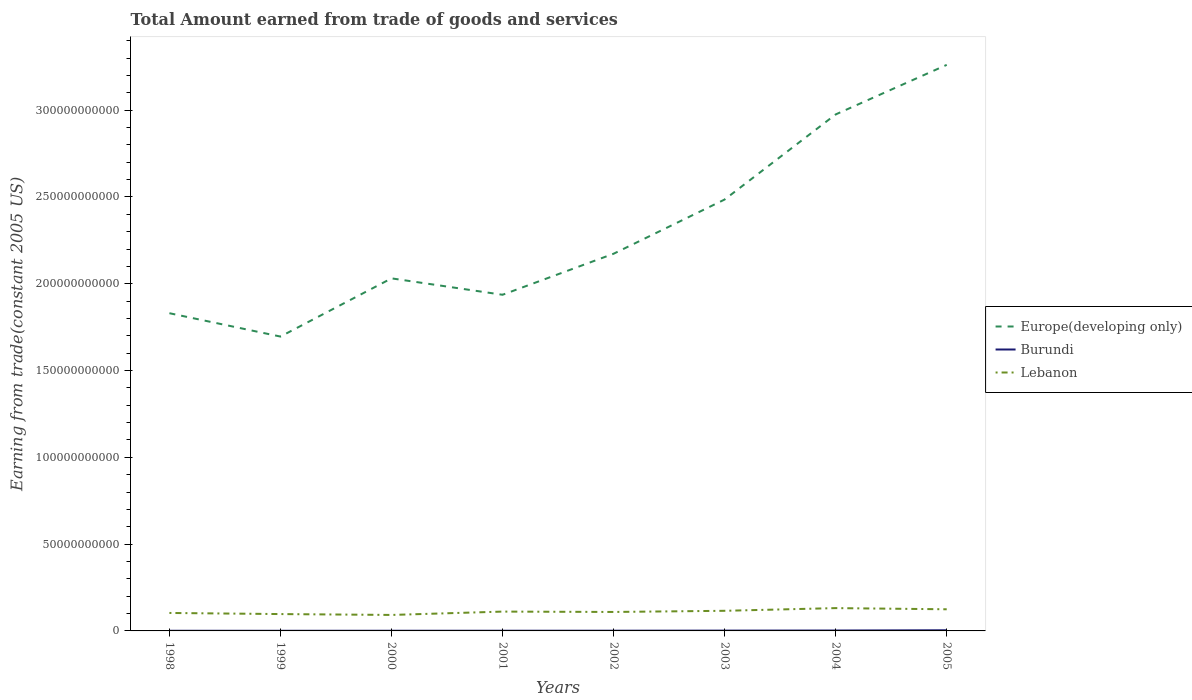Does the line corresponding to Lebanon intersect with the line corresponding to Burundi?
Ensure brevity in your answer.  No. Across all years, what is the maximum total amount earned by trading goods and services in Europe(developing only)?
Give a very brief answer. 1.70e+11. In which year was the total amount earned by trading goods and services in Europe(developing only) maximum?
Keep it short and to the point. 1999. What is the total total amount earned by trading goods and services in Lebanon in the graph?
Make the answer very short. -3.26e+09. What is the difference between the highest and the second highest total amount earned by trading goods and services in Europe(developing only)?
Your response must be concise. 1.57e+11. How many years are there in the graph?
Your response must be concise. 8. Are the values on the major ticks of Y-axis written in scientific E-notation?
Offer a terse response. No. Does the graph contain any zero values?
Ensure brevity in your answer.  No. Does the graph contain grids?
Provide a short and direct response. No. What is the title of the graph?
Offer a very short reply. Total Amount earned from trade of goods and services. What is the label or title of the X-axis?
Give a very brief answer. Years. What is the label or title of the Y-axis?
Provide a succinct answer. Earning from trade(constant 2005 US). What is the Earning from trade(constant 2005 US) of Europe(developing only) in 1998?
Ensure brevity in your answer.  1.83e+11. What is the Earning from trade(constant 2005 US) of Burundi in 1998?
Offer a very short reply. 9.18e+07. What is the Earning from trade(constant 2005 US) of Lebanon in 1998?
Your answer should be very brief. 1.04e+1. What is the Earning from trade(constant 2005 US) of Europe(developing only) in 1999?
Provide a succinct answer. 1.70e+11. What is the Earning from trade(constant 2005 US) in Burundi in 1999?
Ensure brevity in your answer.  8.37e+07. What is the Earning from trade(constant 2005 US) of Lebanon in 1999?
Your response must be concise. 9.71e+09. What is the Earning from trade(constant 2005 US) in Europe(developing only) in 2000?
Your answer should be compact. 2.03e+11. What is the Earning from trade(constant 2005 US) in Burundi in 2000?
Make the answer very short. 9.42e+07. What is the Earning from trade(constant 2005 US) of Lebanon in 2000?
Offer a terse response. 9.20e+09. What is the Earning from trade(constant 2005 US) in Europe(developing only) in 2001?
Provide a succinct answer. 1.94e+11. What is the Earning from trade(constant 2005 US) of Burundi in 2001?
Offer a terse response. 1.10e+08. What is the Earning from trade(constant 2005 US) of Lebanon in 2001?
Offer a very short reply. 1.11e+1. What is the Earning from trade(constant 2005 US) of Europe(developing only) in 2002?
Offer a terse response. 2.17e+11. What is the Earning from trade(constant 2005 US) of Burundi in 2002?
Your answer should be compact. 1.29e+08. What is the Earning from trade(constant 2005 US) of Lebanon in 2002?
Your answer should be compact. 1.09e+1. What is the Earning from trade(constant 2005 US) in Europe(developing only) in 2003?
Your answer should be compact. 2.49e+11. What is the Earning from trade(constant 2005 US) of Burundi in 2003?
Provide a succinct answer. 1.82e+08. What is the Earning from trade(constant 2005 US) in Lebanon in 2003?
Your answer should be compact. 1.16e+1. What is the Earning from trade(constant 2005 US) of Europe(developing only) in 2004?
Give a very brief answer. 2.98e+11. What is the Earning from trade(constant 2005 US) in Burundi in 2004?
Your answer should be compact. 2.31e+08. What is the Earning from trade(constant 2005 US) of Lebanon in 2004?
Your answer should be very brief. 1.31e+1. What is the Earning from trade(constant 2005 US) in Europe(developing only) in 2005?
Offer a very short reply. 3.26e+11. What is the Earning from trade(constant 2005 US) of Burundi in 2005?
Your response must be concise. 3.74e+08. What is the Earning from trade(constant 2005 US) of Lebanon in 2005?
Your answer should be compact. 1.25e+1. Across all years, what is the maximum Earning from trade(constant 2005 US) of Europe(developing only)?
Your answer should be very brief. 3.26e+11. Across all years, what is the maximum Earning from trade(constant 2005 US) in Burundi?
Offer a very short reply. 3.74e+08. Across all years, what is the maximum Earning from trade(constant 2005 US) of Lebanon?
Give a very brief answer. 1.31e+1. Across all years, what is the minimum Earning from trade(constant 2005 US) in Europe(developing only)?
Offer a terse response. 1.70e+11. Across all years, what is the minimum Earning from trade(constant 2005 US) of Burundi?
Offer a terse response. 8.37e+07. Across all years, what is the minimum Earning from trade(constant 2005 US) of Lebanon?
Give a very brief answer. 9.20e+09. What is the total Earning from trade(constant 2005 US) of Europe(developing only) in the graph?
Your answer should be very brief. 1.84e+12. What is the total Earning from trade(constant 2005 US) of Burundi in the graph?
Your answer should be very brief. 1.30e+09. What is the total Earning from trade(constant 2005 US) in Lebanon in the graph?
Keep it short and to the point. 8.85e+1. What is the difference between the Earning from trade(constant 2005 US) in Europe(developing only) in 1998 and that in 1999?
Offer a very short reply. 1.35e+1. What is the difference between the Earning from trade(constant 2005 US) in Burundi in 1998 and that in 1999?
Provide a succinct answer. 8.14e+06. What is the difference between the Earning from trade(constant 2005 US) in Lebanon in 1998 and that in 1999?
Make the answer very short. 6.42e+08. What is the difference between the Earning from trade(constant 2005 US) of Europe(developing only) in 1998 and that in 2000?
Offer a terse response. -2.01e+1. What is the difference between the Earning from trade(constant 2005 US) of Burundi in 1998 and that in 2000?
Keep it short and to the point. -2.43e+06. What is the difference between the Earning from trade(constant 2005 US) of Lebanon in 1998 and that in 2000?
Offer a very short reply. 1.15e+09. What is the difference between the Earning from trade(constant 2005 US) of Europe(developing only) in 1998 and that in 2001?
Provide a short and direct response. -1.06e+1. What is the difference between the Earning from trade(constant 2005 US) in Burundi in 1998 and that in 2001?
Offer a very short reply. -1.86e+07. What is the difference between the Earning from trade(constant 2005 US) of Lebanon in 1998 and that in 2001?
Provide a short and direct response. -7.86e+08. What is the difference between the Earning from trade(constant 2005 US) of Europe(developing only) in 1998 and that in 2002?
Your response must be concise. -3.43e+1. What is the difference between the Earning from trade(constant 2005 US) in Burundi in 1998 and that in 2002?
Keep it short and to the point. -3.75e+07. What is the difference between the Earning from trade(constant 2005 US) in Lebanon in 1998 and that in 2002?
Your answer should be compact. -5.75e+08. What is the difference between the Earning from trade(constant 2005 US) of Europe(developing only) in 1998 and that in 2003?
Keep it short and to the point. -6.55e+1. What is the difference between the Earning from trade(constant 2005 US) in Burundi in 1998 and that in 2003?
Your answer should be very brief. -8.99e+07. What is the difference between the Earning from trade(constant 2005 US) of Lebanon in 1998 and that in 2003?
Your answer should be very brief. -1.24e+09. What is the difference between the Earning from trade(constant 2005 US) in Europe(developing only) in 1998 and that in 2004?
Your answer should be very brief. -1.15e+11. What is the difference between the Earning from trade(constant 2005 US) in Burundi in 1998 and that in 2004?
Your response must be concise. -1.39e+08. What is the difference between the Earning from trade(constant 2005 US) of Lebanon in 1998 and that in 2004?
Keep it short and to the point. -2.79e+09. What is the difference between the Earning from trade(constant 2005 US) of Europe(developing only) in 1998 and that in 2005?
Your response must be concise. -1.43e+11. What is the difference between the Earning from trade(constant 2005 US) of Burundi in 1998 and that in 2005?
Provide a succinct answer. -2.82e+08. What is the difference between the Earning from trade(constant 2005 US) of Lebanon in 1998 and that in 2005?
Your response must be concise. -2.11e+09. What is the difference between the Earning from trade(constant 2005 US) of Europe(developing only) in 1999 and that in 2000?
Keep it short and to the point. -3.35e+1. What is the difference between the Earning from trade(constant 2005 US) in Burundi in 1999 and that in 2000?
Provide a succinct answer. -1.06e+07. What is the difference between the Earning from trade(constant 2005 US) of Lebanon in 1999 and that in 2000?
Ensure brevity in your answer.  5.05e+08. What is the difference between the Earning from trade(constant 2005 US) in Europe(developing only) in 1999 and that in 2001?
Your answer should be compact. -2.41e+1. What is the difference between the Earning from trade(constant 2005 US) in Burundi in 1999 and that in 2001?
Ensure brevity in your answer.  -2.67e+07. What is the difference between the Earning from trade(constant 2005 US) of Lebanon in 1999 and that in 2001?
Ensure brevity in your answer.  -1.43e+09. What is the difference between the Earning from trade(constant 2005 US) of Europe(developing only) in 1999 and that in 2002?
Give a very brief answer. -4.77e+1. What is the difference between the Earning from trade(constant 2005 US) in Burundi in 1999 and that in 2002?
Ensure brevity in your answer.  -4.56e+07. What is the difference between the Earning from trade(constant 2005 US) of Lebanon in 1999 and that in 2002?
Your response must be concise. -1.22e+09. What is the difference between the Earning from trade(constant 2005 US) in Europe(developing only) in 1999 and that in 2003?
Your response must be concise. -7.89e+1. What is the difference between the Earning from trade(constant 2005 US) in Burundi in 1999 and that in 2003?
Your response must be concise. -9.81e+07. What is the difference between the Earning from trade(constant 2005 US) of Lebanon in 1999 and that in 2003?
Ensure brevity in your answer.  -1.88e+09. What is the difference between the Earning from trade(constant 2005 US) of Europe(developing only) in 1999 and that in 2004?
Offer a very short reply. -1.28e+11. What is the difference between the Earning from trade(constant 2005 US) in Burundi in 1999 and that in 2004?
Your answer should be compact. -1.47e+08. What is the difference between the Earning from trade(constant 2005 US) of Lebanon in 1999 and that in 2004?
Give a very brief answer. -3.44e+09. What is the difference between the Earning from trade(constant 2005 US) of Europe(developing only) in 1999 and that in 2005?
Offer a terse response. -1.57e+11. What is the difference between the Earning from trade(constant 2005 US) of Burundi in 1999 and that in 2005?
Provide a succinct answer. -2.90e+08. What is the difference between the Earning from trade(constant 2005 US) in Lebanon in 1999 and that in 2005?
Keep it short and to the point. -2.76e+09. What is the difference between the Earning from trade(constant 2005 US) of Europe(developing only) in 2000 and that in 2001?
Your answer should be compact. 9.45e+09. What is the difference between the Earning from trade(constant 2005 US) in Burundi in 2000 and that in 2001?
Make the answer very short. -1.61e+07. What is the difference between the Earning from trade(constant 2005 US) of Lebanon in 2000 and that in 2001?
Keep it short and to the point. -1.93e+09. What is the difference between the Earning from trade(constant 2005 US) in Europe(developing only) in 2000 and that in 2002?
Give a very brief answer. -1.42e+1. What is the difference between the Earning from trade(constant 2005 US) of Burundi in 2000 and that in 2002?
Offer a terse response. -3.50e+07. What is the difference between the Earning from trade(constant 2005 US) of Lebanon in 2000 and that in 2002?
Provide a succinct answer. -1.72e+09. What is the difference between the Earning from trade(constant 2005 US) in Europe(developing only) in 2000 and that in 2003?
Make the answer very short. -4.54e+1. What is the difference between the Earning from trade(constant 2005 US) of Burundi in 2000 and that in 2003?
Keep it short and to the point. -8.75e+07. What is the difference between the Earning from trade(constant 2005 US) of Lebanon in 2000 and that in 2003?
Your answer should be compact. -2.39e+09. What is the difference between the Earning from trade(constant 2005 US) in Europe(developing only) in 2000 and that in 2004?
Make the answer very short. -9.44e+1. What is the difference between the Earning from trade(constant 2005 US) in Burundi in 2000 and that in 2004?
Your answer should be compact. -1.37e+08. What is the difference between the Earning from trade(constant 2005 US) of Lebanon in 2000 and that in 2004?
Your answer should be very brief. -3.94e+09. What is the difference between the Earning from trade(constant 2005 US) of Europe(developing only) in 2000 and that in 2005?
Ensure brevity in your answer.  -1.23e+11. What is the difference between the Earning from trade(constant 2005 US) of Burundi in 2000 and that in 2005?
Your answer should be compact. -2.79e+08. What is the difference between the Earning from trade(constant 2005 US) in Lebanon in 2000 and that in 2005?
Provide a short and direct response. -3.26e+09. What is the difference between the Earning from trade(constant 2005 US) of Europe(developing only) in 2001 and that in 2002?
Keep it short and to the point. -2.36e+1. What is the difference between the Earning from trade(constant 2005 US) of Burundi in 2001 and that in 2002?
Your response must be concise. -1.89e+07. What is the difference between the Earning from trade(constant 2005 US) in Lebanon in 2001 and that in 2002?
Provide a short and direct response. 2.12e+08. What is the difference between the Earning from trade(constant 2005 US) in Europe(developing only) in 2001 and that in 2003?
Provide a short and direct response. -5.49e+1. What is the difference between the Earning from trade(constant 2005 US) of Burundi in 2001 and that in 2003?
Make the answer very short. -7.14e+07. What is the difference between the Earning from trade(constant 2005 US) of Lebanon in 2001 and that in 2003?
Offer a very short reply. -4.55e+08. What is the difference between the Earning from trade(constant 2005 US) in Europe(developing only) in 2001 and that in 2004?
Provide a succinct answer. -1.04e+11. What is the difference between the Earning from trade(constant 2005 US) of Burundi in 2001 and that in 2004?
Provide a succinct answer. -1.21e+08. What is the difference between the Earning from trade(constant 2005 US) of Lebanon in 2001 and that in 2004?
Your response must be concise. -2.01e+09. What is the difference between the Earning from trade(constant 2005 US) of Europe(developing only) in 2001 and that in 2005?
Ensure brevity in your answer.  -1.32e+11. What is the difference between the Earning from trade(constant 2005 US) of Burundi in 2001 and that in 2005?
Offer a terse response. -2.63e+08. What is the difference between the Earning from trade(constant 2005 US) in Lebanon in 2001 and that in 2005?
Your answer should be compact. -1.33e+09. What is the difference between the Earning from trade(constant 2005 US) in Europe(developing only) in 2002 and that in 2003?
Ensure brevity in your answer.  -3.12e+1. What is the difference between the Earning from trade(constant 2005 US) in Burundi in 2002 and that in 2003?
Give a very brief answer. -5.25e+07. What is the difference between the Earning from trade(constant 2005 US) in Lebanon in 2002 and that in 2003?
Make the answer very short. -6.66e+08. What is the difference between the Earning from trade(constant 2005 US) in Europe(developing only) in 2002 and that in 2004?
Your answer should be compact. -8.03e+1. What is the difference between the Earning from trade(constant 2005 US) in Burundi in 2002 and that in 2004?
Offer a very short reply. -1.02e+08. What is the difference between the Earning from trade(constant 2005 US) in Lebanon in 2002 and that in 2004?
Your answer should be very brief. -2.22e+09. What is the difference between the Earning from trade(constant 2005 US) in Europe(developing only) in 2002 and that in 2005?
Your answer should be very brief. -1.09e+11. What is the difference between the Earning from trade(constant 2005 US) of Burundi in 2002 and that in 2005?
Offer a terse response. -2.44e+08. What is the difference between the Earning from trade(constant 2005 US) in Lebanon in 2002 and that in 2005?
Your response must be concise. -1.54e+09. What is the difference between the Earning from trade(constant 2005 US) of Europe(developing only) in 2003 and that in 2004?
Provide a short and direct response. -4.90e+1. What is the difference between the Earning from trade(constant 2005 US) in Burundi in 2003 and that in 2004?
Provide a short and direct response. -4.93e+07. What is the difference between the Earning from trade(constant 2005 US) of Lebanon in 2003 and that in 2004?
Provide a succinct answer. -1.55e+09. What is the difference between the Earning from trade(constant 2005 US) in Europe(developing only) in 2003 and that in 2005?
Ensure brevity in your answer.  -7.76e+1. What is the difference between the Earning from trade(constant 2005 US) of Burundi in 2003 and that in 2005?
Make the answer very short. -1.92e+08. What is the difference between the Earning from trade(constant 2005 US) of Lebanon in 2003 and that in 2005?
Keep it short and to the point. -8.73e+08. What is the difference between the Earning from trade(constant 2005 US) in Europe(developing only) in 2004 and that in 2005?
Ensure brevity in your answer.  -2.85e+1. What is the difference between the Earning from trade(constant 2005 US) in Burundi in 2004 and that in 2005?
Provide a succinct answer. -1.43e+08. What is the difference between the Earning from trade(constant 2005 US) in Lebanon in 2004 and that in 2005?
Provide a succinct answer. 6.80e+08. What is the difference between the Earning from trade(constant 2005 US) in Europe(developing only) in 1998 and the Earning from trade(constant 2005 US) in Burundi in 1999?
Your response must be concise. 1.83e+11. What is the difference between the Earning from trade(constant 2005 US) of Europe(developing only) in 1998 and the Earning from trade(constant 2005 US) of Lebanon in 1999?
Provide a short and direct response. 1.73e+11. What is the difference between the Earning from trade(constant 2005 US) in Burundi in 1998 and the Earning from trade(constant 2005 US) in Lebanon in 1999?
Provide a short and direct response. -9.62e+09. What is the difference between the Earning from trade(constant 2005 US) in Europe(developing only) in 1998 and the Earning from trade(constant 2005 US) in Burundi in 2000?
Give a very brief answer. 1.83e+11. What is the difference between the Earning from trade(constant 2005 US) of Europe(developing only) in 1998 and the Earning from trade(constant 2005 US) of Lebanon in 2000?
Give a very brief answer. 1.74e+11. What is the difference between the Earning from trade(constant 2005 US) of Burundi in 1998 and the Earning from trade(constant 2005 US) of Lebanon in 2000?
Offer a very short reply. -9.11e+09. What is the difference between the Earning from trade(constant 2005 US) of Europe(developing only) in 1998 and the Earning from trade(constant 2005 US) of Burundi in 2001?
Offer a very short reply. 1.83e+11. What is the difference between the Earning from trade(constant 2005 US) in Europe(developing only) in 1998 and the Earning from trade(constant 2005 US) in Lebanon in 2001?
Make the answer very short. 1.72e+11. What is the difference between the Earning from trade(constant 2005 US) in Burundi in 1998 and the Earning from trade(constant 2005 US) in Lebanon in 2001?
Your response must be concise. -1.10e+1. What is the difference between the Earning from trade(constant 2005 US) in Europe(developing only) in 1998 and the Earning from trade(constant 2005 US) in Burundi in 2002?
Give a very brief answer. 1.83e+11. What is the difference between the Earning from trade(constant 2005 US) in Europe(developing only) in 1998 and the Earning from trade(constant 2005 US) in Lebanon in 2002?
Your response must be concise. 1.72e+11. What is the difference between the Earning from trade(constant 2005 US) in Burundi in 1998 and the Earning from trade(constant 2005 US) in Lebanon in 2002?
Give a very brief answer. -1.08e+1. What is the difference between the Earning from trade(constant 2005 US) in Europe(developing only) in 1998 and the Earning from trade(constant 2005 US) in Burundi in 2003?
Make the answer very short. 1.83e+11. What is the difference between the Earning from trade(constant 2005 US) of Europe(developing only) in 1998 and the Earning from trade(constant 2005 US) of Lebanon in 2003?
Offer a terse response. 1.71e+11. What is the difference between the Earning from trade(constant 2005 US) of Burundi in 1998 and the Earning from trade(constant 2005 US) of Lebanon in 2003?
Ensure brevity in your answer.  -1.15e+1. What is the difference between the Earning from trade(constant 2005 US) in Europe(developing only) in 1998 and the Earning from trade(constant 2005 US) in Burundi in 2004?
Give a very brief answer. 1.83e+11. What is the difference between the Earning from trade(constant 2005 US) of Europe(developing only) in 1998 and the Earning from trade(constant 2005 US) of Lebanon in 2004?
Ensure brevity in your answer.  1.70e+11. What is the difference between the Earning from trade(constant 2005 US) of Burundi in 1998 and the Earning from trade(constant 2005 US) of Lebanon in 2004?
Ensure brevity in your answer.  -1.31e+1. What is the difference between the Earning from trade(constant 2005 US) of Europe(developing only) in 1998 and the Earning from trade(constant 2005 US) of Burundi in 2005?
Keep it short and to the point. 1.83e+11. What is the difference between the Earning from trade(constant 2005 US) of Europe(developing only) in 1998 and the Earning from trade(constant 2005 US) of Lebanon in 2005?
Your response must be concise. 1.71e+11. What is the difference between the Earning from trade(constant 2005 US) of Burundi in 1998 and the Earning from trade(constant 2005 US) of Lebanon in 2005?
Your answer should be compact. -1.24e+1. What is the difference between the Earning from trade(constant 2005 US) in Europe(developing only) in 1999 and the Earning from trade(constant 2005 US) in Burundi in 2000?
Provide a succinct answer. 1.69e+11. What is the difference between the Earning from trade(constant 2005 US) of Europe(developing only) in 1999 and the Earning from trade(constant 2005 US) of Lebanon in 2000?
Provide a succinct answer. 1.60e+11. What is the difference between the Earning from trade(constant 2005 US) in Burundi in 1999 and the Earning from trade(constant 2005 US) in Lebanon in 2000?
Provide a short and direct response. -9.12e+09. What is the difference between the Earning from trade(constant 2005 US) of Europe(developing only) in 1999 and the Earning from trade(constant 2005 US) of Burundi in 2001?
Offer a terse response. 1.69e+11. What is the difference between the Earning from trade(constant 2005 US) of Europe(developing only) in 1999 and the Earning from trade(constant 2005 US) of Lebanon in 2001?
Provide a short and direct response. 1.58e+11. What is the difference between the Earning from trade(constant 2005 US) in Burundi in 1999 and the Earning from trade(constant 2005 US) in Lebanon in 2001?
Make the answer very short. -1.11e+1. What is the difference between the Earning from trade(constant 2005 US) in Europe(developing only) in 1999 and the Earning from trade(constant 2005 US) in Burundi in 2002?
Offer a terse response. 1.69e+11. What is the difference between the Earning from trade(constant 2005 US) in Europe(developing only) in 1999 and the Earning from trade(constant 2005 US) in Lebanon in 2002?
Make the answer very short. 1.59e+11. What is the difference between the Earning from trade(constant 2005 US) of Burundi in 1999 and the Earning from trade(constant 2005 US) of Lebanon in 2002?
Your answer should be compact. -1.08e+1. What is the difference between the Earning from trade(constant 2005 US) of Europe(developing only) in 1999 and the Earning from trade(constant 2005 US) of Burundi in 2003?
Give a very brief answer. 1.69e+11. What is the difference between the Earning from trade(constant 2005 US) in Europe(developing only) in 1999 and the Earning from trade(constant 2005 US) in Lebanon in 2003?
Your answer should be very brief. 1.58e+11. What is the difference between the Earning from trade(constant 2005 US) in Burundi in 1999 and the Earning from trade(constant 2005 US) in Lebanon in 2003?
Offer a terse response. -1.15e+1. What is the difference between the Earning from trade(constant 2005 US) in Europe(developing only) in 1999 and the Earning from trade(constant 2005 US) in Burundi in 2004?
Your response must be concise. 1.69e+11. What is the difference between the Earning from trade(constant 2005 US) in Europe(developing only) in 1999 and the Earning from trade(constant 2005 US) in Lebanon in 2004?
Your answer should be compact. 1.56e+11. What is the difference between the Earning from trade(constant 2005 US) in Burundi in 1999 and the Earning from trade(constant 2005 US) in Lebanon in 2004?
Offer a terse response. -1.31e+1. What is the difference between the Earning from trade(constant 2005 US) in Europe(developing only) in 1999 and the Earning from trade(constant 2005 US) in Burundi in 2005?
Ensure brevity in your answer.  1.69e+11. What is the difference between the Earning from trade(constant 2005 US) of Europe(developing only) in 1999 and the Earning from trade(constant 2005 US) of Lebanon in 2005?
Provide a succinct answer. 1.57e+11. What is the difference between the Earning from trade(constant 2005 US) of Burundi in 1999 and the Earning from trade(constant 2005 US) of Lebanon in 2005?
Offer a very short reply. -1.24e+1. What is the difference between the Earning from trade(constant 2005 US) of Europe(developing only) in 2000 and the Earning from trade(constant 2005 US) of Burundi in 2001?
Your answer should be compact. 2.03e+11. What is the difference between the Earning from trade(constant 2005 US) in Europe(developing only) in 2000 and the Earning from trade(constant 2005 US) in Lebanon in 2001?
Ensure brevity in your answer.  1.92e+11. What is the difference between the Earning from trade(constant 2005 US) of Burundi in 2000 and the Earning from trade(constant 2005 US) of Lebanon in 2001?
Your answer should be very brief. -1.10e+1. What is the difference between the Earning from trade(constant 2005 US) in Europe(developing only) in 2000 and the Earning from trade(constant 2005 US) in Burundi in 2002?
Make the answer very short. 2.03e+11. What is the difference between the Earning from trade(constant 2005 US) of Europe(developing only) in 2000 and the Earning from trade(constant 2005 US) of Lebanon in 2002?
Provide a succinct answer. 1.92e+11. What is the difference between the Earning from trade(constant 2005 US) in Burundi in 2000 and the Earning from trade(constant 2005 US) in Lebanon in 2002?
Offer a very short reply. -1.08e+1. What is the difference between the Earning from trade(constant 2005 US) of Europe(developing only) in 2000 and the Earning from trade(constant 2005 US) of Burundi in 2003?
Your answer should be compact. 2.03e+11. What is the difference between the Earning from trade(constant 2005 US) of Europe(developing only) in 2000 and the Earning from trade(constant 2005 US) of Lebanon in 2003?
Provide a short and direct response. 1.92e+11. What is the difference between the Earning from trade(constant 2005 US) of Burundi in 2000 and the Earning from trade(constant 2005 US) of Lebanon in 2003?
Give a very brief answer. -1.15e+1. What is the difference between the Earning from trade(constant 2005 US) in Europe(developing only) in 2000 and the Earning from trade(constant 2005 US) in Burundi in 2004?
Your response must be concise. 2.03e+11. What is the difference between the Earning from trade(constant 2005 US) in Europe(developing only) in 2000 and the Earning from trade(constant 2005 US) in Lebanon in 2004?
Give a very brief answer. 1.90e+11. What is the difference between the Earning from trade(constant 2005 US) in Burundi in 2000 and the Earning from trade(constant 2005 US) in Lebanon in 2004?
Offer a terse response. -1.31e+1. What is the difference between the Earning from trade(constant 2005 US) in Europe(developing only) in 2000 and the Earning from trade(constant 2005 US) in Burundi in 2005?
Your answer should be very brief. 2.03e+11. What is the difference between the Earning from trade(constant 2005 US) in Europe(developing only) in 2000 and the Earning from trade(constant 2005 US) in Lebanon in 2005?
Offer a very short reply. 1.91e+11. What is the difference between the Earning from trade(constant 2005 US) in Burundi in 2000 and the Earning from trade(constant 2005 US) in Lebanon in 2005?
Your response must be concise. -1.24e+1. What is the difference between the Earning from trade(constant 2005 US) in Europe(developing only) in 2001 and the Earning from trade(constant 2005 US) in Burundi in 2002?
Your response must be concise. 1.94e+11. What is the difference between the Earning from trade(constant 2005 US) of Europe(developing only) in 2001 and the Earning from trade(constant 2005 US) of Lebanon in 2002?
Provide a succinct answer. 1.83e+11. What is the difference between the Earning from trade(constant 2005 US) in Burundi in 2001 and the Earning from trade(constant 2005 US) in Lebanon in 2002?
Provide a short and direct response. -1.08e+1. What is the difference between the Earning from trade(constant 2005 US) in Europe(developing only) in 2001 and the Earning from trade(constant 2005 US) in Burundi in 2003?
Your response must be concise. 1.93e+11. What is the difference between the Earning from trade(constant 2005 US) of Europe(developing only) in 2001 and the Earning from trade(constant 2005 US) of Lebanon in 2003?
Make the answer very short. 1.82e+11. What is the difference between the Earning from trade(constant 2005 US) of Burundi in 2001 and the Earning from trade(constant 2005 US) of Lebanon in 2003?
Keep it short and to the point. -1.15e+1. What is the difference between the Earning from trade(constant 2005 US) of Europe(developing only) in 2001 and the Earning from trade(constant 2005 US) of Burundi in 2004?
Your response must be concise. 1.93e+11. What is the difference between the Earning from trade(constant 2005 US) in Europe(developing only) in 2001 and the Earning from trade(constant 2005 US) in Lebanon in 2004?
Give a very brief answer. 1.81e+11. What is the difference between the Earning from trade(constant 2005 US) of Burundi in 2001 and the Earning from trade(constant 2005 US) of Lebanon in 2004?
Provide a short and direct response. -1.30e+1. What is the difference between the Earning from trade(constant 2005 US) of Europe(developing only) in 2001 and the Earning from trade(constant 2005 US) of Burundi in 2005?
Offer a very short reply. 1.93e+11. What is the difference between the Earning from trade(constant 2005 US) in Europe(developing only) in 2001 and the Earning from trade(constant 2005 US) in Lebanon in 2005?
Offer a very short reply. 1.81e+11. What is the difference between the Earning from trade(constant 2005 US) in Burundi in 2001 and the Earning from trade(constant 2005 US) in Lebanon in 2005?
Make the answer very short. -1.24e+1. What is the difference between the Earning from trade(constant 2005 US) in Europe(developing only) in 2002 and the Earning from trade(constant 2005 US) in Burundi in 2003?
Provide a succinct answer. 2.17e+11. What is the difference between the Earning from trade(constant 2005 US) in Europe(developing only) in 2002 and the Earning from trade(constant 2005 US) in Lebanon in 2003?
Provide a succinct answer. 2.06e+11. What is the difference between the Earning from trade(constant 2005 US) of Burundi in 2002 and the Earning from trade(constant 2005 US) of Lebanon in 2003?
Your answer should be compact. -1.15e+1. What is the difference between the Earning from trade(constant 2005 US) in Europe(developing only) in 2002 and the Earning from trade(constant 2005 US) in Burundi in 2004?
Your response must be concise. 2.17e+11. What is the difference between the Earning from trade(constant 2005 US) of Europe(developing only) in 2002 and the Earning from trade(constant 2005 US) of Lebanon in 2004?
Your answer should be compact. 2.04e+11. What is the difference between the Earning from trade(constant 2005 US) of Burundi in 2002 and the Earning from trade(constant 2005 US) of Lebanon in 2004?
Keep it short and to the point. -1.30e+1. What is the difference between the Earning from trade(constant 2005 US) of Europe(developing only) in 2002 and the Earning from trade(constant 2005 US) of Burundi in 2005?
Make the answer very short. 2.17e+11. What is the difference between the Earning from trade(constant 2005 US) in Europe(developing only) in 2002 and the Earning from trade(constant 2005 US) in Lebanon in 2005?
Keep it short and to the point. 2.05e+11. What is the difference between the Earning from trade(constant 2005 US) in Burundi in 2002 and the Earning from trade(constant 2005 US) in Lebanon in 2005?
Your response must be concise. -1.23e+1. What is the difference between the Earning from trade(constant 2005 US) of Europe(developing only) in 2003 and the Earning from trade(constant 2005 US) of Burundi in 2004?
Provide a succinct answer. 2.48e+11. What is the difference between the Earning from trade(constant 2005 US) in Europe(developing only) in 2003 and the Earning from trade(constant 2005 US) in Lebanon in 2004?
Your answer should be compact. 2.35e+11. What is the difference between the Earning from trade(constant 2005 US) in Burundi in 2003 and the Earning from trade(constant 2005 US) in Lebanon in 2004?
Offer a terse response. -1.30e+1. What is the difference between the Earning from trade(constant 2005 US) of Europe(developing only) in 2003 and the Earning from trade(constant 2005 US) of Burundi in 2005?
Provide a short and direct response. 2.48e+11. What is the difference between the Earning from trade(constant 2005 US) in Europe(developing only) in 2003 and the Earning from trade(constant 2005 US) in Lebanon in 2005?
Provide a short and direct response. 2.36e+11. What is the difference between the Earning from trade(constant 2005 US) of Burundi in 2003 and the Earning from trade(constant 2005 US) of Lebanon in 2005?
Your answer should be very brief. -1.23e+1. What is the difference between the Earning from trade(constant 2005 US) in Europe(developing only) in 2004 and the Earning from trade(constant 2005 US) in Burundi in 2005?
Give a very brief answer. 2.97e+11. What is the difference between the Earning from trade(constant 2005 US) of Europe(developing only) in 2004 and the Earning from trade(constant 2005 US) of Lebanon in 2005?
Keep it short and to the point. 2.85e+11. What is the difference between the Earning from trade(constant 2005 US) in Burundi in 2004 and the Earning from trade(constant 2005 US) in Lebanon in 2005?
Your answer should be compact. -1.22e+1. What is the average Earning from trade(constant 2005 US) in Europe(developing only) per year?
Make the answer very short. 2.30e+11. What is the average Earning from trade(constant 2005 US) in Burundi per year?
Offer a very short reply. 1.62e+08. What is the average Earning from trade(constant 2005 US) of Lebanon per year?
Your answer should be very brief. 1.11e+1. In the year 1998, what is the difference between the Earning from trade(constant 2005 US) in Europe(developing only) and Earning from trade(constant 2005 US) in Burundi?
Provide a short and direct response. 1.83e+11. In the year 1998, what is the difference between the Earning from trade(constant 2005 US) of Europe(developing only) and Earning from trade(constant 2005 US) of Lebanon?
Make the answer very short. 1.73e+11. In the year 1998, what is the difference between the Earning from trade(constant 2005 US) of Burundi and Earning from trade(constant 2005 US) of Lebanon?
Give a very brief answer. -1.03e+1. In the year 1999, what is the difference between the Earning from trade(constant 2005 US) in Europe(developing only) and Earning from trade(constant 2005 US) in Burundi?
Ensure brevity in your answer.  1.70e+11. In the year 1999, what is the difference between the Earning from trade(constant 2005 US) of Europe(developing only) and Earning from trade(constant 2005 US) of Lebanon?
Provide a succinct answer. 1.60e+11. In the year 1999, what is the difference between the Earning from trade(constant 2005 US) in Burundi and Earning from trade(constant 2005 US) in Lebanon?
Make the answer very short. -9.62e+09. In the year 2000, what is the difference between the Earning from trade(constant 2005 US) of Europe(developing only) and Earning from trade(constant 2005 US) of Burundi?
Keep it short and to the point. 2.03e+11. In the year 2000, what is the difference between the Earning from trade(constant 2005 US) of Europe(developing only) and Earning from trade(constant 2005 US) of Lebanon?
Keep it short and to the point. 1.94e+11. In the year 2000, what is the difference between the Earning from trade(constant 2005 US) of Burundi and Earning from trade(constant 2005 US) of Lebanon?
Your answer should be compact. -9.11e+09. In the year 2001, what is the difference between the Earning from trade(constant 2005 US) of Europe(developing only) and Earning from trade(constant 2005 US) of Burundi?
Make the answer very short. 1.94e+11. In the year 2001, what is the difference between the Earning from trade(constant 2005 US) of Europe(developing only) and Earning from trade(constant 2005 US) of Lebanon?
Offer a very short reply. 1.83e+11. In the year 2001, what is the difference between the Earning from trade(constant 2005 US) of Burundi and Earning from trade(constant 2005 US) of Lebanon?
Offer a terse response. -1.10e+1. In the year 2002, what is the difference between the Earning from trade(constant 2005 US) of Europe(developing only) and Earning from trade(constant 2005 US) of Burundi?
Ensure brevity in your answer.  2.17e+11. In the year 2002, what is the difference between the Earning from trade(constant 2005 US) in Europe(developing only) and Earning from trade(constant 2005 US) in Lebanon?
Your response must be concise. 2.06e+11. In the year 2002, what is the difference between the Earning from trade(constant 2005 US) of Burundi and Earning from trade(constant 2005 US) of Lebanon?
Give a very brief answer. -1.08e+1. In the year 2003, what is the difference between the Earning from trade(constant 2005 US) in Europe(developing only) and Earning from trade(constant 2005 US) in Burundi?
Your response must be concise. 2.48e+11. In the year 2003, what is the difference between the Earning from trade(constant 2005 US) of Europe(developing only) and Earning from trade(constant 2005 US) of Lebanon?
Your answer should be compact. 2.37e+11. In the year 2003, what is the difference between the Earning from trade(constant 2005 US) in Burundi and Earning from trade(constant 2005 US) in Lebanon?
Give a very brief answer. -1.14e+1. In the year 2004, what is the difference between the Earning from trade(constant 2005 US) of Europe(developing only) and Earning from trade(constant 2005 US) of Burundi?
Provide a short and direct response. 2.97e+11. In the year 2004, what is the difference between the Earning from trade(constant 2005 US) of Europe(developing only) and Earning from trade(constant 2005 US) of Lebanon?
Your response must be concise. 2.84e+11. In the year 2004, what is the difference between the Earning from trade(constant 2005 US) in Burundi and Earning from trade(constant 2005 US) in Lebanon?
Provide a succinct answer. -1.29e+1. In the year 2005, what is the difference between the Earning from trade(constant 2005 US) in Europe(developing only) and Earning from trade(constant 2005 US) in Burundi?
Offer a very short reply. 3.26e+11. In the year 2005, what is the difference between the Earning from trade(constant 2005 US) in Europe(developing only) and Earning from trade(constant 2005 US) in Lebanon?
Give a very brief answer. 3.14e+11. In the year 2005, what is the difference between the Earning from trade(constant 2005 US) in Burundi and Earning from trade(constant 2005 US) in Lebanon?
Provide a succinct answer. -1.21e+1. What is the ratio of the Earning from trade(constant 2005 US) in Europe(developing only) in 1998 to that in 1999?
Your response must be concise. 1.08. What is the ratio of the Earning from trade(constant 2005 US) in Burundi in 1998 to that in 1999?
Your answer should be compact. 1.1. What is the ratio of the Earning from trade(constant 2005 US) of Lebanon in 1998 to that in 1999?
Your response must be concise. 1.07. What is the ratio of the Earning from trade(constant 2005 US) in Europe(developing only) in 1998 to that in 2000?
Keep it short and to the point. 0.9. What is the ratio of the Earning from trade(constant 2005 US) of Burundi in 1998 to that in 2000?
Keep it short and to the point. 0.97. What is the ratio of the Earning from trade(constant 2005 US) in Lebanon in 1998 to that in 2000?
Your answer should be compact. 1.12. What is the ratio of the Earning from trade(constant 2005 US) of Europe(developing only) in 1998 to that in 2001?
Provide a short and direct response. 0.95. What is the ratio of the Earning from trade(constant 2005 US) in Burundi in 1998 to that in 2001?
Provide a short and direct response. 0.83. What is the ratio of the Earning from trade(constant 2005 US) in Lebanon in 1998 to that in 2001?
Make the answer very short. 0.93. What is the ratio of the Earning from trade(constant 2005 US) of Europe(developing only) in 1998 to that in 2002?
Your response must be concise. 0.84. What is the ratio of the Earning from trade(constant 2005 US) of Burundi in 1998 to that in 2002?
Ensure brevity in your answer.  0.71. What is the ratio of the Earning from trade(constant 2005 US) of Lebanon in 1998 to that in 2002?
Ensure brevity in your answer.  0.95. What is the ratio of the Earning from trade(constant 2005 US) of Europe(developing only) in 1998 to that in 2003?
Give a very brief answer. 0.74. What is the ratio of the Earning from trade(constant 2005 US) of Burundi in 1998 to that in 2003?
Ensure brevity in your answer.  0.51. What is the ratio of the Earning from trade(constant 2005 US) of Lebanon in 1998 to that in 2003?
Make the answer very short. 0.89. What is the ratio of the Earning from trade(constant 2005 US) of Europe(developing only) in 1998 to that in 2004?
Provide a short and direct response. 0.62. What is the ratio of the Earning from trade(constant 2005 US) of Burundi in 1998 to that in 2004?
Keep it short and to the point. 0.4. What is the ratio of the Earning from trade(constant 2005 US) of Lebanon in 1998 to that in 2004?
Keep it short and to the point. 0.79. What is the ratio of the Earning from trade(constant 2005 US) in Europe(developing only) in 1998 to that in 2005?
Provide a short and direct response. 0.56. What is the ratio of the Earning from trade(constant 2005 US) in Burundi in 1998 to that in 2005?
Your answer should be compact. 0.25. What is the ratio of the Earning from trade(constant 2005 US) in Lebanon in 1998 to that in 2005?
Keep it short and to the point. 0.83. What is the ratio of the Earning from trade(constant 2005 US) in Europe(developing only) in 1999 to that in 2000?
Your answer should be very brief. 0.83. What is the ratio of the Earning from trade(constant 2005 US) of Burundi in 1999 to that in 2000?
Your answer should be compact. 0.89. What is the ratio of the Earning from trade(constant 2005 US) in Lebanon in 1999 to that in 2000?
Offer a very short reply. 1.05. What is the ratio of the Earning from trade(constant 2005 US) of Europe(developing only) in 1999 to that in 2001?
Offer a very short reply. 0.88. What is the ratio of the Earning from trade(constant 2005 US) in Burundi in 1999 to that in 2001?
Your response must be concise. 0.76. What is the ratio of the Earning from trade(constant 2005 US) in Lebanon in 1999 to that in 2001?
Provide a succinct answer. 0.87. What is the ratio of the Earning from trade(constant 2005 US) of Europe(developing only) in 1999 to that in 2002?
Keep it short and to the point. 0.78. What is the ratio of the Earning from trade(constant 2005 US) in Burundi in 1999 to that in 2002?
Make the answer very short. 0.65. What is the ratio of the Earning from trade(constant 2005 US) of Lebanon in 1999 to that in 2002?
Offer a terse response. 0.89. What is the ratio of the Earning from trade(constant 2005 US) of Europe(developing only) in 1999 to that in 2003?
Your answer should be very brief. 0.68. What is the ratio of the Earning from trade(constant 2005 US) in Burundi in 1999 to that in 2003?
Offer a very short reply. 0.46. What is the ratio of the Earning from trade(constant 2005 US) in Lebanon in 1999 to that in 2003?
Offer a terse response. 0.84. What is the ratio of the Earning from trade(constant 2005 US) in Europe(developing only) in 1999 to that in 2004?
Provide a succinct answer. 0.57. What is the ratio of the Earning from trade(constant 2005 US) of Burundi in 1999 to that in 2004?
Provide a short and direct response. 0.36. What is the ratio of the Earning from trade(constant 2005 US) in Lebanon in 1999 to that in 2004?
Offer a terse response. 0.74. What is the ratio of the Earning from trade(constant 2005 US) of Europe(developing only) in 1999 to that in 2005?
Provide a succinct answer. 0.52. What is the ratio of the Earning from trade(constant 2005 US) in Burundi in 1999 to that in 2005?
Offer a very short reply. 0.22. What is the ratio of the Earning from trade(constant 2005 US) in Lebanon in 1999 to that in 2005?
Ensure brevity in your answer.  0.78. What is the ratio of the Earning from trade(constant 2005 US) in Europe(developing only) in 2000 to that in 2001?
Offer a terse response. 1.05. What is the ratio of the Earning from trade(constant 2005 US) of Burundi in 2000 to that in 2001?
Keep it short and to the point. 0.85. What is the ratio of the Earning from trade(constant 2005 US) of Lebanon in 2000 to that in 2001?
Your answer should be compact. 0.83. What is the ratio of the Earning from trade(constant 2005 US) of Europe(developing only) in 2000 to that in 2002?
Offer a very short reply. 0.93. What is the ratio of the Earning from trade(constant 2005 US) of Burundi in 2000 to that in 2002?
Make the answer very short. 0.73. What is the ratio of the Earning from trade(constant 2005 US) of Lebanon in 2000 to that in 2002?
Give a very brief answer. 0.84. What is the ratio of the Earning from trade(constant 2005 US) of Europe(developing only) in 2000 to that in 2003?
Offer a terse response. 0.82. What is the ratio of the Earning from trade(constant 2005 US) in Burundi in 2000 to that in 2003?
Provide a short and direct response. 0.52. What is the ratio of the Earning from trade(constant 2005 US) in Lebanon in 2000 to that in 2003?
Offer a very short reply. 0.79. What is the ratio of the Earning from trade(constant 2005 US) of Europe(developing only) in 2000 to that in 2004?
Your answer should be compact. 0.68. What is the ratio of the Earning from trade(constant 2005 US) in Burundi in 2000 to that in 2004?
Keep it short and to the point. 0.41. What is the ratio of the Earning from trade(constant 2005 US) in Lebanon in 2000 to that in 2004?
Your response must be concise. 0.7. What is the ratio of the Earning from trade(constant 2005 US) in Europe(developing only) in 2000 to that in 2005?
Provide a short and direct response. 0.62. What is the ratio of the Earning from trade(constant 2005 US) of Burundi in 2000 to that in 2005?
Your response must be concise. 0.25. What is the ratio of the Earning from trade(constant 2005 US) in Lebanon in 2000 to that in 2005?
Your response must be concise. 0.74. What is the ratio of the Earning from trade(constant 2005 US) in Europe(developing only) in 2001 to that in 2002?
Your response must be concise. 0.89. What is the ratio of the Earning from trade(constant 2005 US) in Burundi in 2001 to that in 2002?
Your answer should be compact. 0.85. What is the ratio of the Earning from trade(constant 2005 US) of Lebanon in 2001 to that in 2002?
Provide a short and direct response. 1.02. What is the ratio of the Earning from trade(constant 2005 US) of Europe(developing only) in 2001 to that in 2003?
Give a very brief answer. 0.78. What is the ratio of the Earning from trade(constant 2005 US) of Burundi in 2001 to that in 2003?
Give a very brief answer. 0.61. What is the ratio of the Earning from trade(constant 2005 US) in Lebanon in 2001 to that in 2003?
Provide a short and direct response. 0.96. What is the ratio of the Earning from trade(constant 2005 US) of Europe(developing only) in 2001 to that in 2004?
Offer a terse response. 0.65. What is the ratio of the Earning from trade(constant 2005 US) of Burundi in 2001 to that in 2004?
Give a very brief answer. 0.48. What is the ratio of the Earning from trade(constant 2005 US) in Lebanon in 2001 to that in 2004?
Your answer should be compact. 0.85. What is the ratio of the Earning from trade(constant 2005 US) in Europe(developing only) in 2001 to that in 2005?
Ensure brevity in your answer.  0.59. What is the ratio of the Earning from trade(constant 2005 US) in Burundi in 2001 to that in 2005?
Offer a terse response. 0.3. What is the ratio of the Earning from trade(constant 2005 US) of Lebanon in 2001 to that in 2005?
Offer a very short reply. 0.89. What is the ratio of the Earning from trade(constant 2005 US) in Europe(developing only) in 2002 to that in 2003?
Offer a very short reply. 0.87. What is the ratio of the Earning from trade(constant 2005 US) of Burundi in 2002 to that in 2003?
Your answer should be compact. 0.71. What is the ratio of the Earning from trade(constant 2005 US) in Lebanon in 2002 to that in 2003?
Make the answer very short. 0.94. What is the ratio of the Earning from trade(constant 2005 US) of Europe(developing only) in 2002 to that in 2004?
Provide a short and direct response. 0.73. What is the ratio of the Earning from trade(constant 2005 US) in Burundi in 2002 to that in 2004?
Your answer should be very brief. 0.56. What is the ratio of the Earning from trade(constant 2005 US) in Lebanon in 2002 to that in 2004?
Give a very brief answer. 0.83. What is the ratio of the Earning from trade(constant 2005 US) of Europe(developing only) in 2002 to that in 2005?
Make the answer very short. 0.67. What is the ratio of the Earning from trade(constant 2005 US) of Burundi in 2002 to that in 2005?
Offer a terse response. 0.35. What is the ratio of the Earning from trade(constant 2005 US) in Lebanon in 2002 to that in 2005?
Your answer should be very brief. 0.88. What is the ratio of the Earning from trade(constant 2005 US) in Europe(developing only) in 2003 to that in 2004?
Your answer should be compact. 0.84. What is the ratio of the Earning from trade(constant 2005 US) of Burundi in 2003 to that in 2004?
Provide a succinct answer. 0.79. What is the ratio of the Earning from trade(constant 2005 US) in Lebanon in 2003 to that in 2004?
Provide a short and direct response. 0.88. What is the ratio of the Earning from trade(constant 2005 US) in Europe(developing only) in 2003 to that in 2005?
Your response must be concise. 0.76. What is the ratio of the Earning from trade(constant 2005 US) of Burundi in 2003 to that in 2005?
Make the answer very short. 0.49. What is the ratio of the Earning from trade(constant 2005 US) in Europe(developing only) in 2004 to that in 2005?
Offer a very short reply. 0.91. What is the ratio of the Earning from trade(constant 2005 US) of Burundi in 2004 to that in 2005?
Your answer should be compact. 0.62. What is the ratio of the Earning from trade(constant 2005 US) of Lebanon in 2004 to that in 2005?
Offer a very short reply. 1.05. What is the difference between the highest and the second highest Earning from trade(constant 2005 US) in Europe(developing only)?
Provide a short and direct response. 2.85e+1. What is the difference between the highest and the second highest Earning from trade(constant 2005 US) of Burundi?
Your response must be concise. 1.43e+08. What is the difference between the highest and the second highest Earning from trade(constant 2005 US) in Lebanon?
Keep it short and to the point. 6.80e+08. What is the difference between the highest and the lowest Earning from trade(constant 2005 US) in Europe(developing only)?
Your response must be concise. 1.57e+11. What is the difference between the highest and the lowest Earning from trade(constant 2005 US) of Burundi?
Your answer should be very brief. 2.90e+08. What is the difference between the highest and the lowest Earning from trade(constant 2005 US) in Lebanon?
Offer a very short reply. 3.94e+09. 